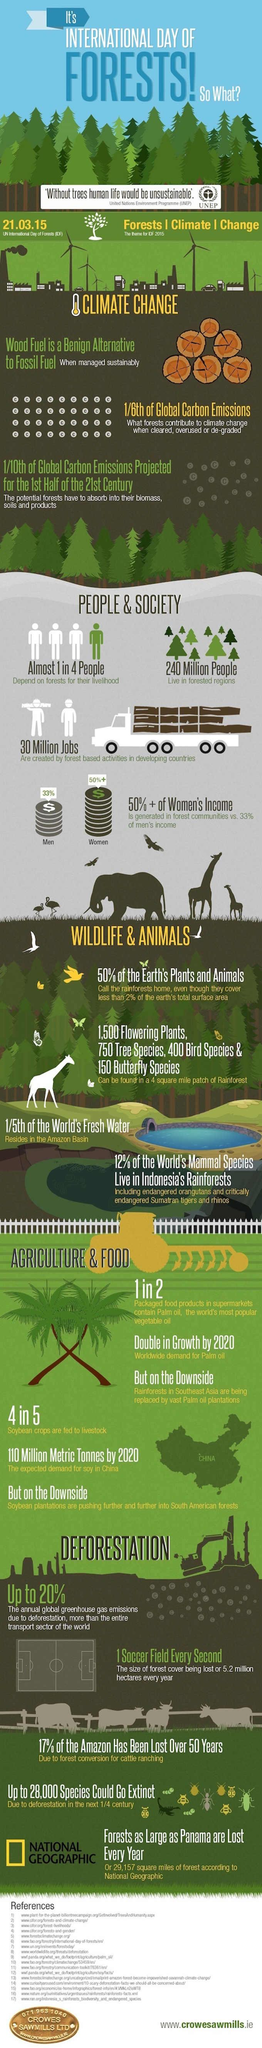Point out several critical features in this image. In forest communities, approximately 33% of men's incomes are generated. On March 21, 2015, the International Day of Forests was celebrated. There are approximately 240 million people who call the forested regions their home. Approximately 12% of the world's mammal species can be found living in Indonesia's rainforests. 